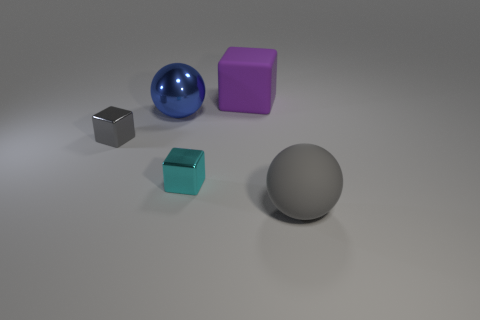There is a tiny block that is the same color as the rubber ball; what material is it?
Your response must be concise. Metal. What shape is the matte object that is in front of the small cyan cube?
Your answer should be very brief. Sphere. Are there an equal number of cyan metallic objects on the left side of the small gray metallic block and large purple blocks to the left of the small cyan object?
Your answer should be very brief. Yes. There is a thing that is behind the tiny gray shiny cube and on the left side of the large purple cube; what color is it?
Ensure brevity in your answer.  Blue. There is a gray object in front of the metal block that is to the right of the big metal object; what is it made of?
Offer a terse response. Rubber. Do the rubber cube and the cyan thing have the same size?
Your response must be concise. No. How many small things are either green cylinders or blue spheres?
Provide a succinct answer. 0. What number of purple blocks are on the left side of the purple cube?
Make the answer very short. 0. Is the number of shiny spheres that are behind the small gray object greater than the number of cyan metallic cylinders?
Give a very brief answer. Yes. There is a big object that is the same material as the gray cube; what shape is it?
Your response must be concise. Sphere. 